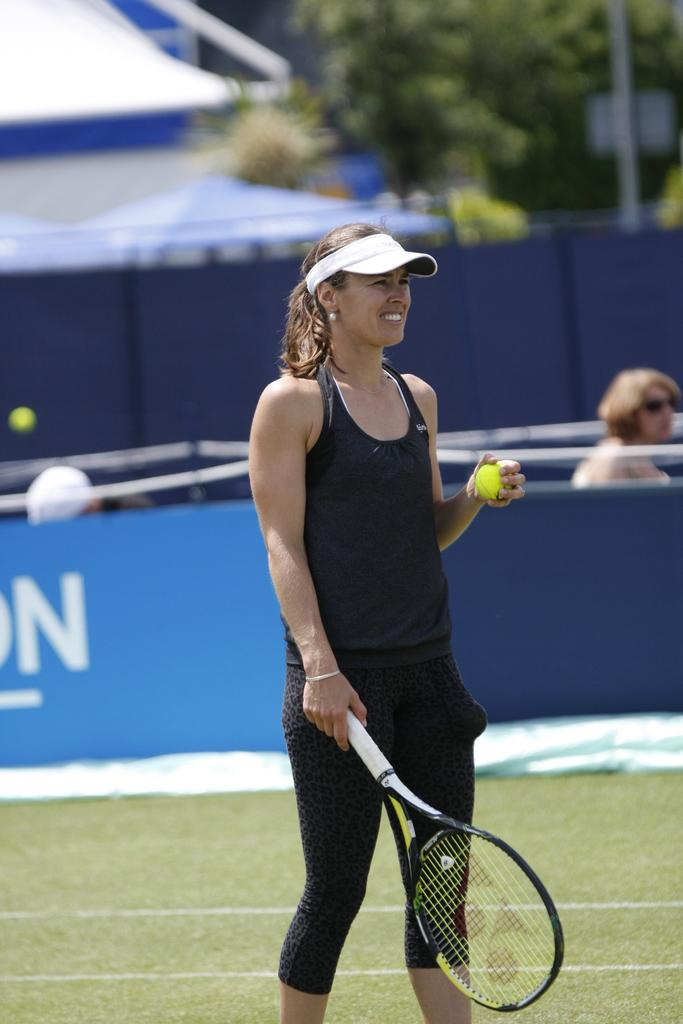What activity are the people in the image engaged in? The people in the image are sitting around a table. What food and drink are present in the image? The people are eating pizza and drinking soda. What is the position of the office in the image? There is no office present in the image; it features a group of people sitting around a table eating pizza and drinking soda. What type of stick is being used by the people in the image? There is no stick present in the image; the people are eating pizza and drinking soda. 